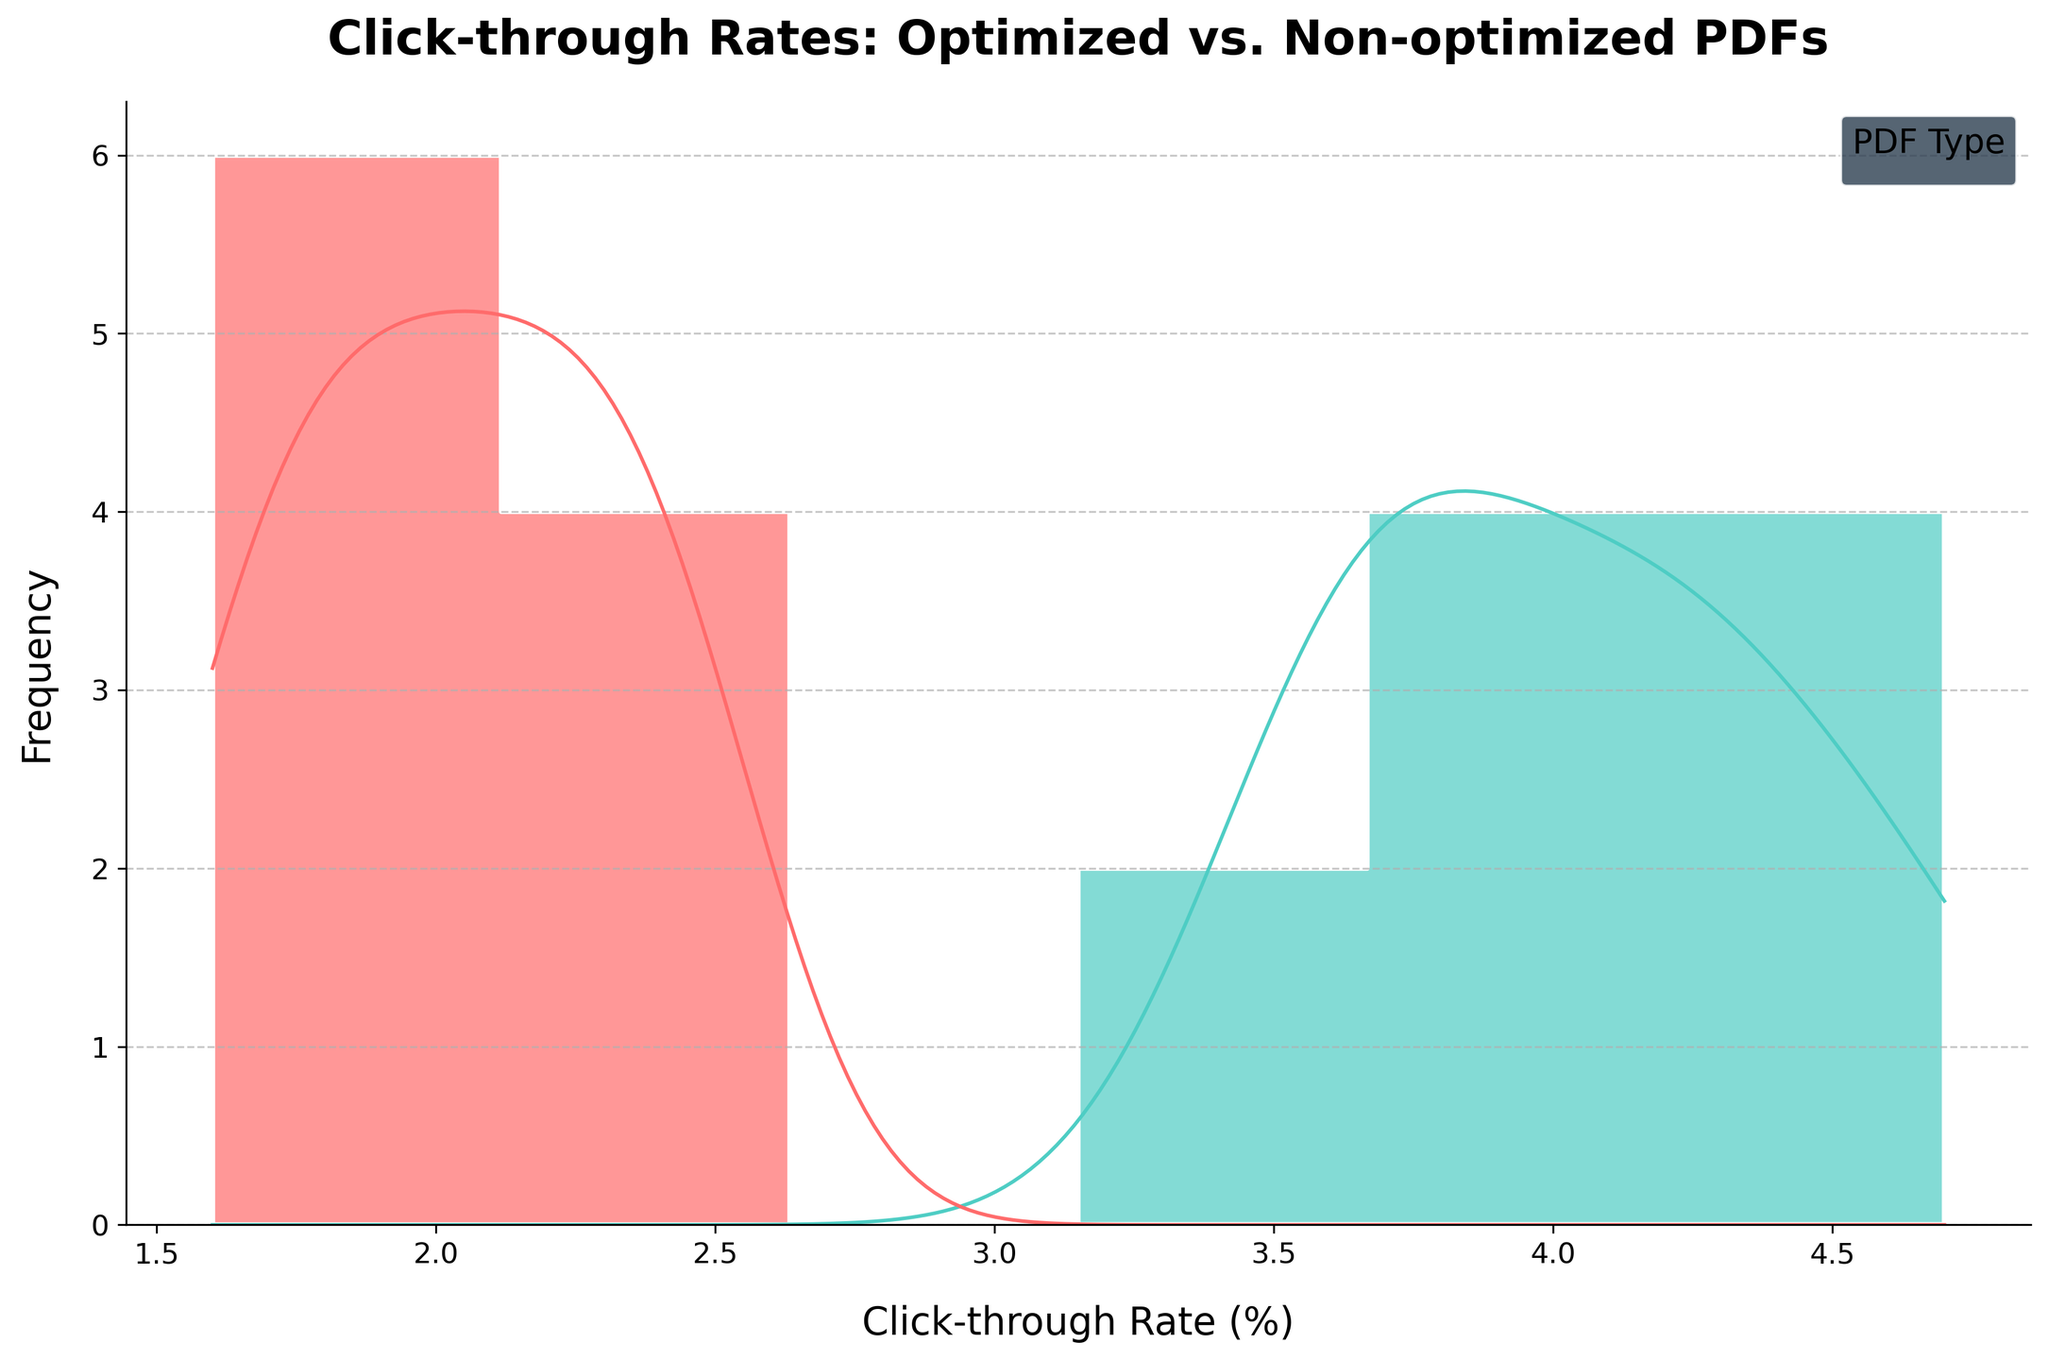What is the title of the plot? The title of a plot is often displayed at the top and provides an overview of what the plot is showing. Here, the title is "Click-through Rates: Optimized vs. Non-optimized PDFs".
Answer: Click-through Rates: Optimized vs. Non-optimized PDFs Which axis represents the Click-through Rate (%)? The X-axis (horizontal axis) often represents different categories or continuous values. In this plot, the X-axis shows the Click-through Rate (%).
Answer: X-axis (horizontal) What color represents the non-optimized PDFs in the plot? In the legend of the plot, the non-optimized PDFs are represented by a specific color. According to the provided data, the color is a shade of red, specifically '#FF6B6B'.
Answer: Red How many peaks are visible in the density curve for the optimized PDFs? The density curve (KDE) provides a smooth estimate of the distribution of data. To find the peaks, observe the curves corresponding to the optimized PDFs. There is one clear peak.
Answer: One What is the approximate click-through rate value where the density curve for optimized PDFs peaks? The peak of the KDE curve represents the mode of the distribution. By examining the plot, the peak for the optimized PDFs is around 4%.
Answer: Around 4% What is a noticeable difference between the click-through rates of optimized and non-optimized PDFs? Comparing the density curves and histograms of the two types of PDFs, we see that optimized PDFs have higher click-through rates overall, with their peak around 4%, while non-optimized PDFs have their peak around 2%.
Answer: Optimized PDFs have higher click-through rates How do the ranges (spread) of click-through rates compare between optimized and non-optimized PDFs? Observing the histograms and KDE plots, the range of click-through rates for optimized PDFs spans approximately from 3.5% to 4.7%, while non-optimized PDFs span from 1.6% to 2.5%.
Answer: Optimized: 3.5% to 4.7%, Non-optimized: 1.6% to 2.5% Which type of PDF has a more tightly clustered click-through rate according to the density curves? Tightly clustered rates would have a sharper and narrower KDE peak. The KDE for non-optimized PDFs is wider and flatter, whereas the optimized PDFs show a sharper peak.
Answer: Optimized PDFs What is the frequency of click-through rates around 2% for non-optimized PDFs? The histogram bar height indicates the frequency of data points. For non-optimized PDFs around 2%, the frequency is higher, suggesting a concentration of values in that range.
Answer: Relatively high Which type of PDF appears to be more effective for email marketing based on click-through rates? Based on the KDE and histogram, optimized PDFs have higher and more concentrated click-through rates around 4%. Higher click-through rates indicate better effectiveness.
Answer: Optimized PDFs 